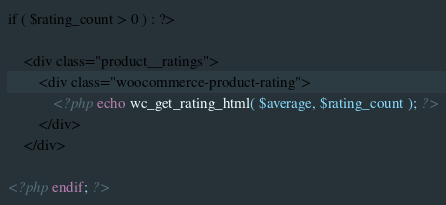<code> <loc_0><loc_0><loc_500><loc_500><_PHP_>
if ( $rating_count > 0 ) : ?>

	<div class="product__ratings">
		<div class="woocommerce-product-rating">
			<?php echo wc_get_rating_html( $average, $rating_count ); ?>
		</div>
	</div>

<?php endif; ?>
</code> 